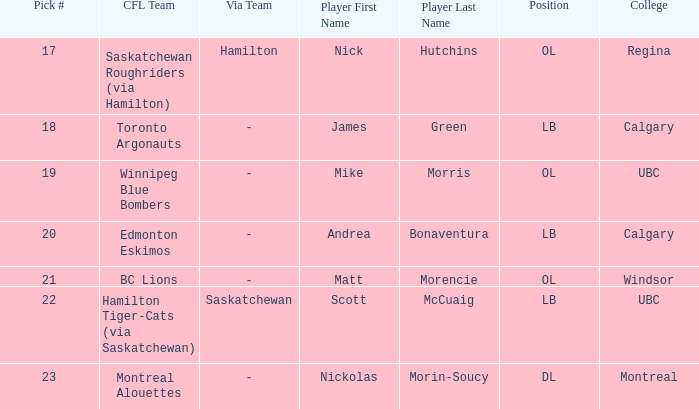Which player is on the BC Lions?  Matt Morencie. 